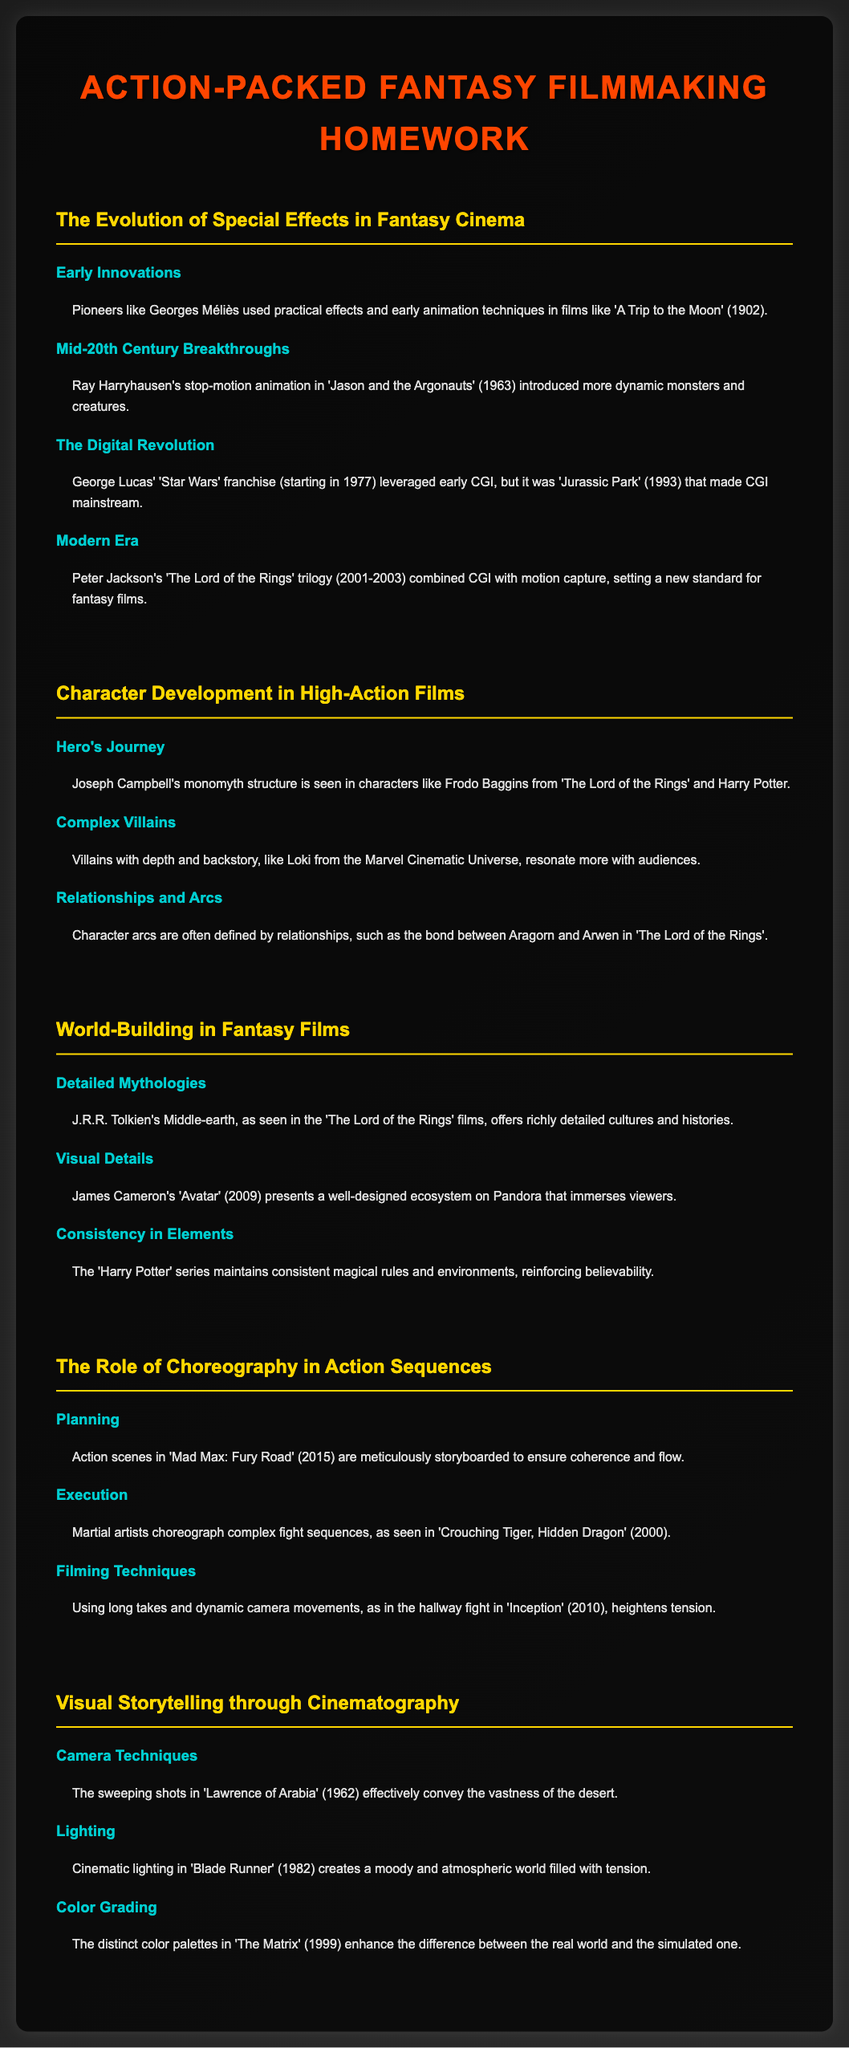What year was 'A Trip to the Moon' released? 'A Trip to the Moon' is mentioned in the context of early special effects innovations, stating it was released in 1902.
Answer: 1902 Who is noted for stop-motion animation in 'Jason and the Argonauts'? The document attributes stop-motion animation and dynamic monsters to Ray Harryhausen in 'Jason and the Argonauts.'
Answer: Ray Harryhausen Which franchise made CGI mainstream in 1993? The text specifically mentions 'Jurassic Park' as the film that made CGI mainstream in 1993.
Answer: Jurassic Park What structure is Joseph Campbell known for in hero development? The document mentions that Joseph Campbell's structure is referred to as the monomyth in discussing character development.
Answer: Monomyth Which character's journey exemplifies the Hero's Journey structure? The document cites Frodo Baggins from 'The Lord of the Rings' as a clear example of the Hero's Journey.
Answer: Frodo Baggins What is a key aspect of J.R.R. Tolkien's Middle-earth as seen in films? The document describes Middle-earth as offering richly detailed cultures and histories.
Answer: Detailed cultures What film is cited for its meticulous storyboarding in action sequences? 'Mad Max: Fury Road' is expressly noted for its meticulous planning of action scenes.
Answer: Mad Max: Fury Road Which film uses dynamic camera movements to heighten tension? The document specifically references 'Inception' for its use of dynamic camera techniques in action scenes.
Answer: Inception What year was 'The Matrix' released? The document refers to 'The Matrix' in discussing color grading, which indicates it was released in 1999.
Answer: 1999 